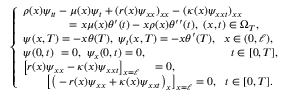Convert formula to latex. <formula><loc_0><loc_0><loc_500><loc_500>\begin{array} { r } { \left \{ \begin{array} { l c } { \rho ( x ) \psi _ { t t } - \mu ( x ) \psi _ { t } + ( r ( x ) \psi _ { x x } ) _ { x x } - ( \kappa ( x ) \psi _ { x x t } ) _ { x x } } \\ { \quad = x \mu ( x ) \theta ^ { \prime } ( t ) - x \rho ( x ) \theta ^ { \prime \prime } ( t ) , \ ( x , t ) \in \Omega _ { T } , } \\ { \psi ( x , T ) = - x \theta ( T ) , \psi _ { t } ( x , T ) = - x \theta ^ { \prime } ( T ) , \, x \in ( 0 , \ell ) , } \\ { \psi ( 0 , t ) \ = 0 , \psi _ { x } ( 0 , t ) = 0 , \quad \ \, t \in [ 0 , T ] , } \\ { \left [ r ( x ) \psi _ { x x } - \kappa ( x ) \psi _ { x x t } \right ] _ { x = \ell } \quad = 0 , } \\ { \quad \left [ \left ( - r ( x ) \psi _ { x x } + \kappa ( x ) \psi _ { x x t } \right ) _ { x } \right ] _ { x = \ell } = 0 , \ \ t \in [ 0 , T ] . } \end{array} } \end{array}</formula> 